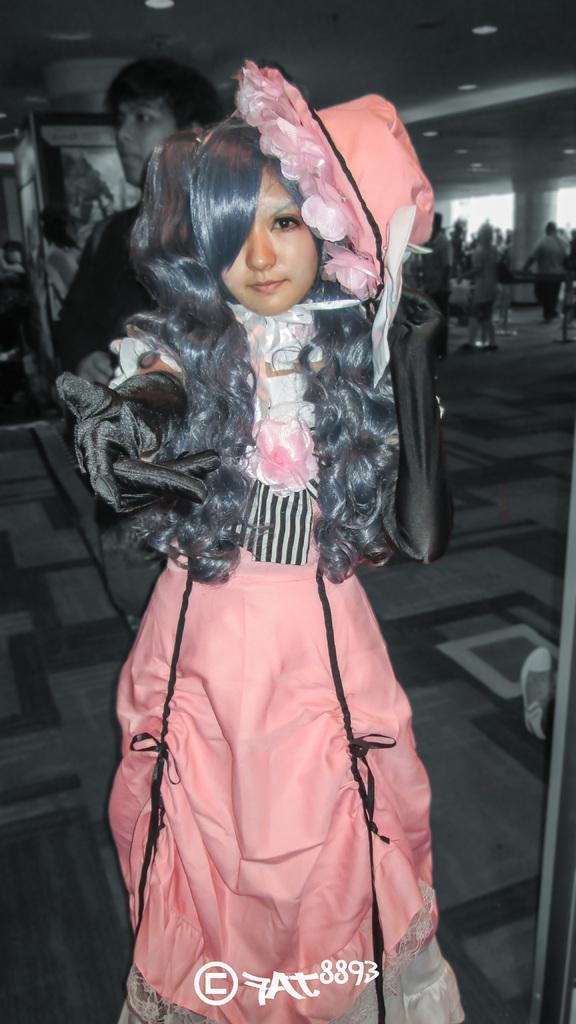Please provide a concise description of this image. There is a woman standing. In the background we can see people and floor. Top we can see lights. 